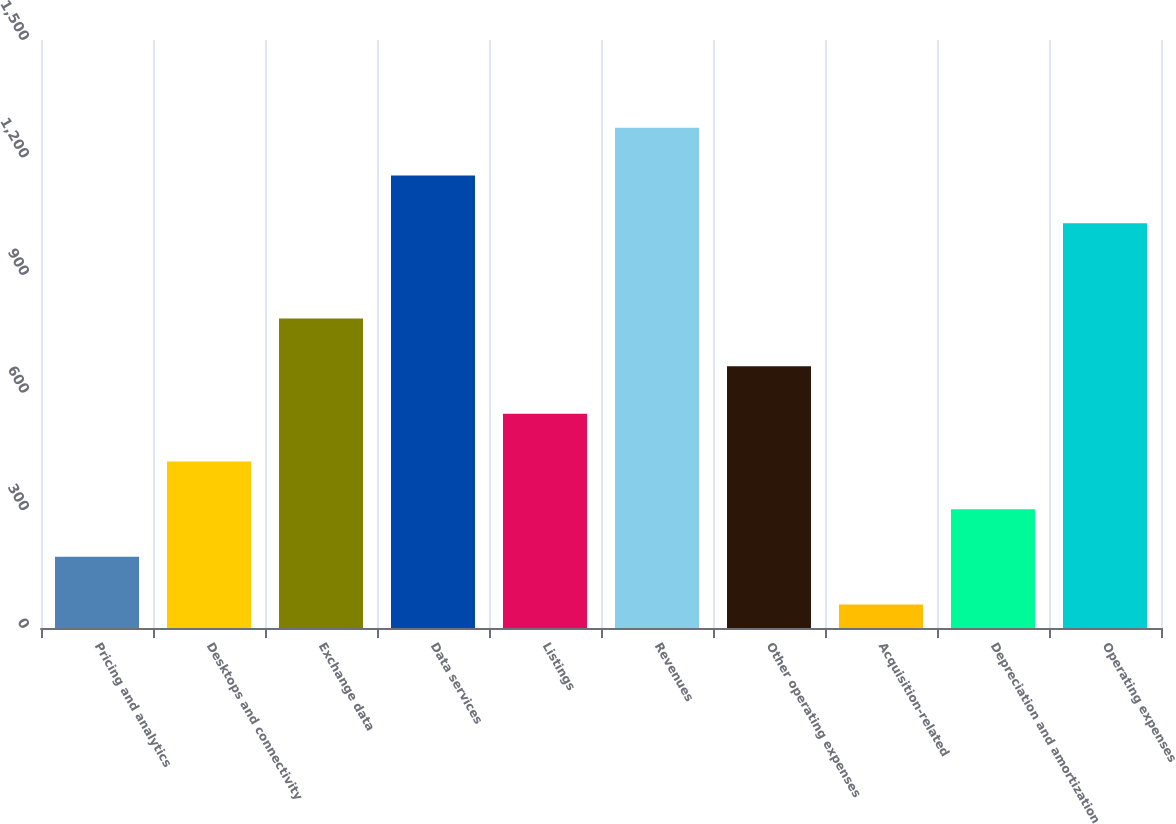Convert chart. <chart><loc_0><loc_0><loc_500><loc_500><bar_chart><fcel>Pricing and analytics<fcel>Desktops and connectivity<fcel>Exchange data<fcel>Data services<fcel>Listings<fcel>Revenues<fcel>Other operating expenses<fcel>Acquisition-related<fcel>Depreciation and amortization<fcel>Operating expenses<nl><fcel>181.6<fcel>424.8<fcel>789.6<fcel>1154.4<fcel>546.4<fcel>1276<fcel>668<fcel>60<fcel>303.2<fcel>1032.8<nl></chart> 